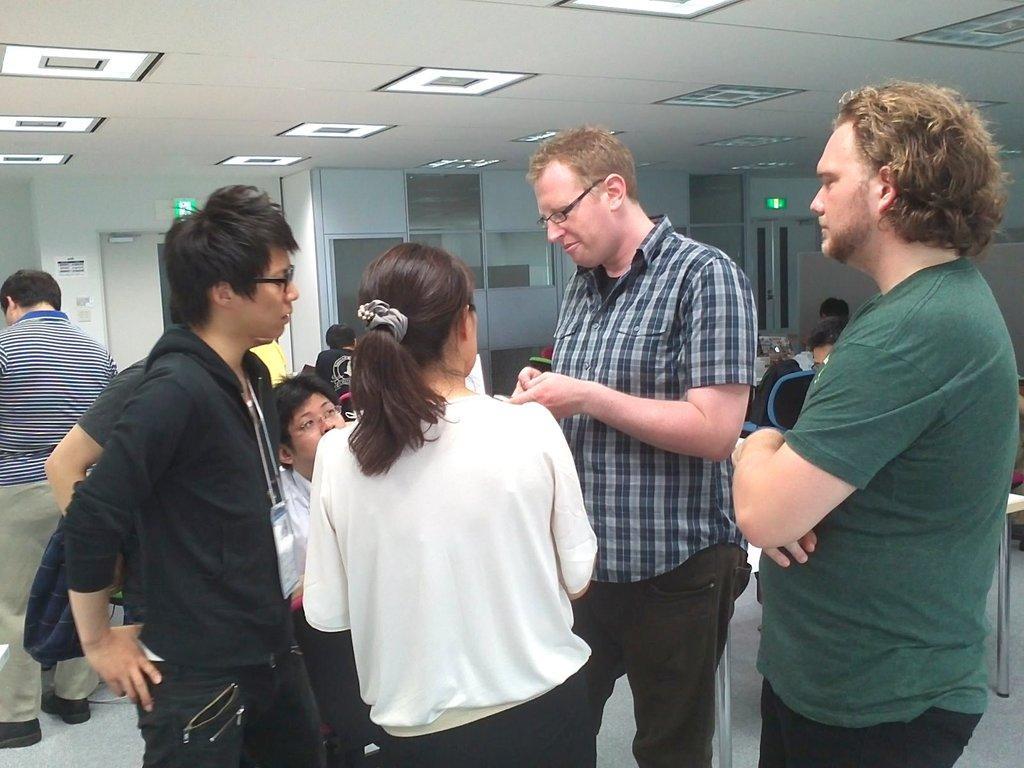Can you describe this image briefly? In this picture there are people and we can see table on the floor and chair. In the background of the image we can see posts on the wall and door. At the top of the image we can see lights. 